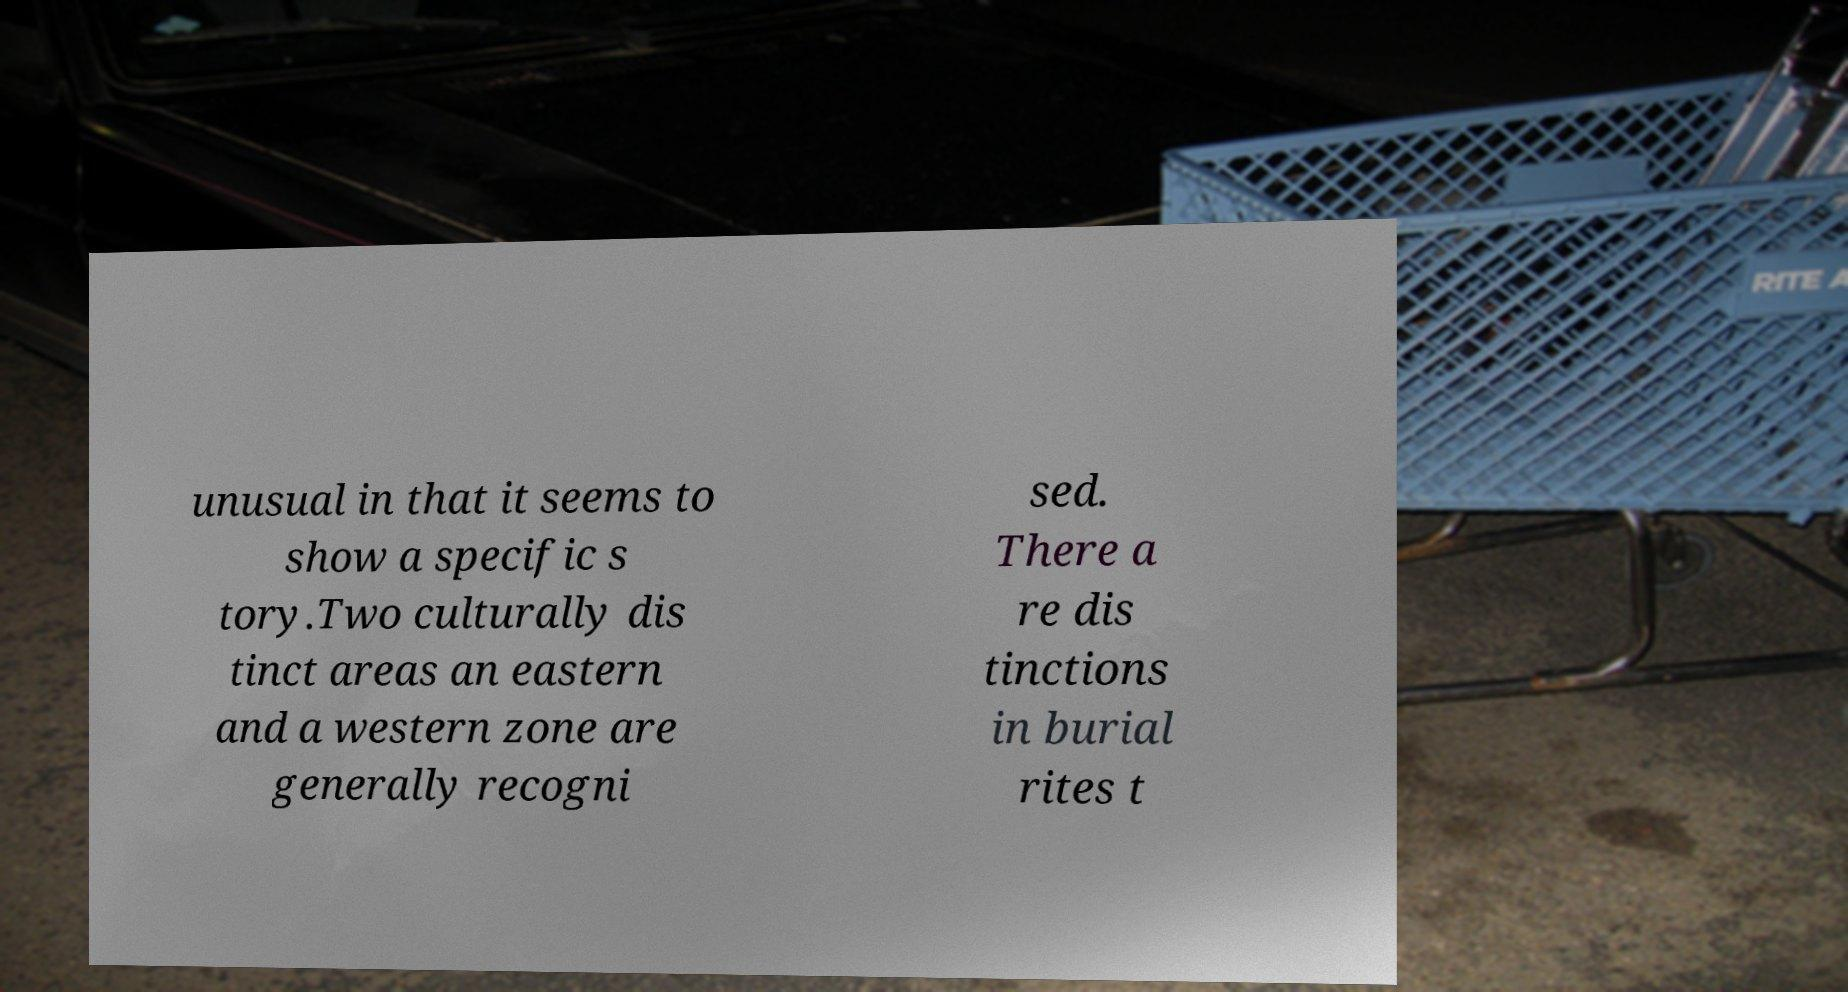I need the written content from this picture converted into text. Can you do that? unusual in that it seems to show a specific s tory.Two culturally dis tinct areas an eastern and a western zone are generally recogni sed. There a re dis tinctions in burial rites t 